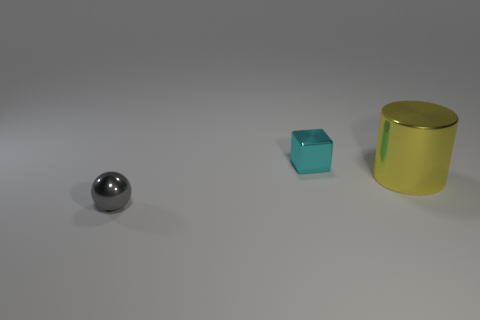Add 3 big yellow cylinders. How many objects exist? 6 Subtract all balls. How many objects are left? 2 Add 1 gray things. How many gray things are left? 2 Add 1 cyan rubber objects. How many cyan rubber objects exist? 1 Subtract 0 cyan cylinders. How many objects are left? 3 Subtract all large yellow shiny objects. Subtract all tiny shiny cubes. How many objects are left? 1 